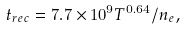<formula> <loc_0><loc_0><loc_500><loc_500>t _ { r e c } = 7 . 7 \times 1 0 ^ { 9 } T ^ { 0 . 6 4 } / n _ { e } ,</formula> 